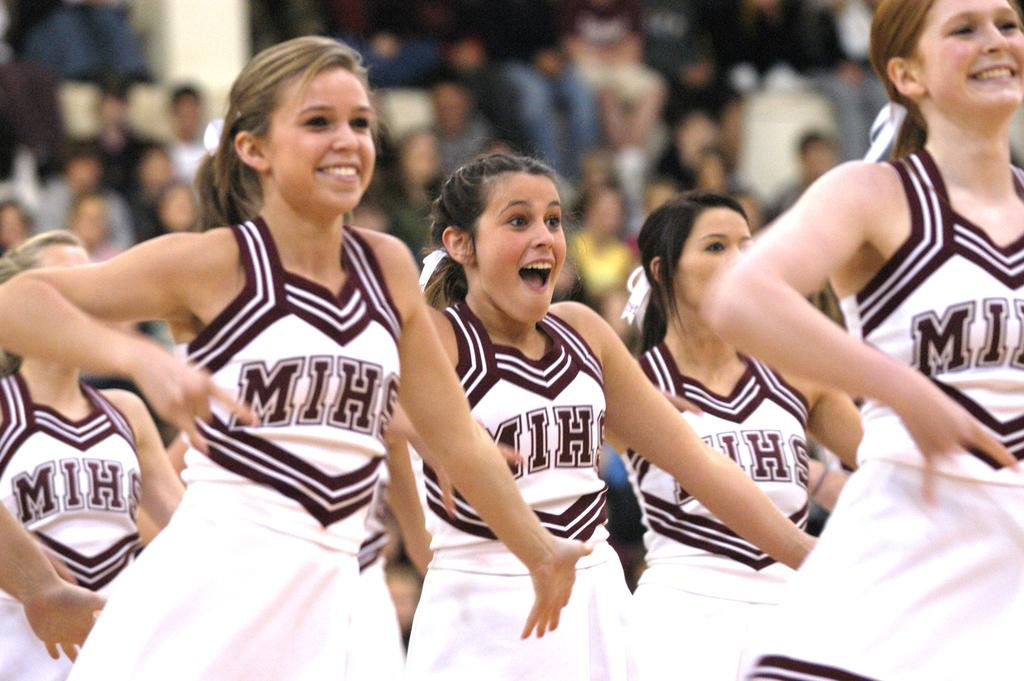Provide a one-sentence caption for the provided image. A group of cheerleaders with the girls wearing MIHS uniforms. 